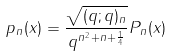Convert formula to latex. <formula><loc_0><loc_0><loc_500><loc_500>p _ { n } ( x ) = \frac { \sqrt { ( q ; q ) _ { n } } } { q ^ { n ^ { 2 } + n + \frac { 1 } { 4 } } } P _ { n } ( x )</formula> 